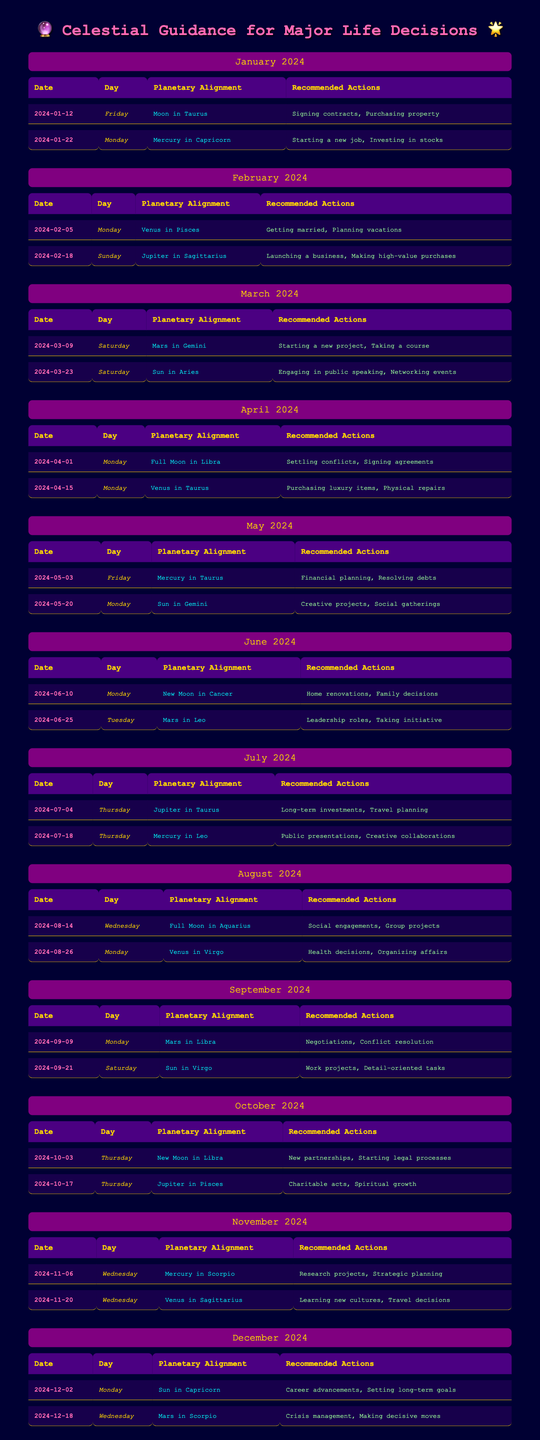What are the favorable days for signing contracts in January 2024? The table shows January's favorable days, with the first being January 12, where the recommended action is signing contracts. The other date, January 22, focuses on starting a new job.
Answer: January 12 Which planetary alignment is associated with family decisions in June 2024? In June 2024, June 10 is listed with the planetary alignment of New Moon in Cancer, and the recommended action includes family decisions.
Answer: New Moon in Cancer How many favorable days are there in total for August 2024? The table for August 2024 lists two favorable days: August 14 and August 26. Thus, the total is 2.
Answer: 2 On which day in October 2024 is initiating new partnerships recommended? The table indicates October 3, 2024, as a favorable day for new partnerships, with the associated planetary alignment being New Moon in Libra.
Answer: October 3 Is there a recommended action for making high-value purchases in February 2024? Yes, February 18, 2024, indicates the recommended action of making high-value purchases alongside launching a business.
Answer: Yes Which month has the maximum number of favorable days? Each month, from January to December, has two favorable days listed, making it consistent throughout the year.
Answer: None (All months have two favorable days) What is the average number of recommended actions for favorable days in April 2024? In April, there are two favorable days, each with two recommended actions (settling conflicts, signing agreements, purchasing luxury items, physical repairs). The total is 4 actions across 2 days, leading to an average of 4/2 = 2.
Answer: 2 When is the best time to plan vacations according to February's forecast? February 5, 2024, is highlighted as the best time for planning vacations, linked with the planetary alignment of Venus in Pisces.
Answer: February 5 What planetary alignment is associated with conflict resolution in September 2024? The table indicates that September 9 features the planetary alignment of Mars in Libra, with the recommended action focusing on conflict resolution.
Answer: Mars in Libra On what date in March 2024 should one focus on starting a new project? March 9, 2024, is the date specified for starting a new project, aligned with Mars in Gemini.
Answer: March 9 